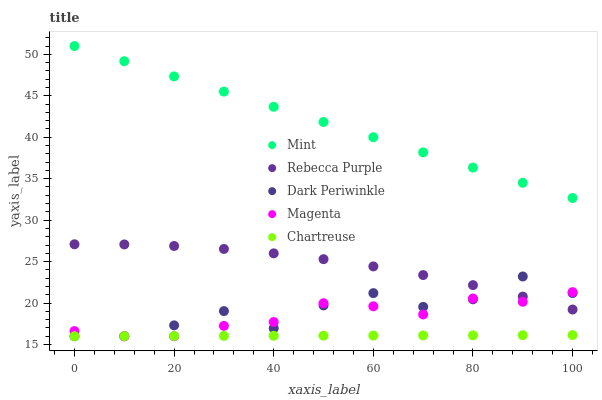Does Chartreuse have the minimum area under the curve?
Answer yes or no. Yes. Does Mint have the maximum area under the curve?
Answer yes or no. Yes. Does Rebecca Purple have the minimum area under the curve?
Answer yes or no. No. Does Rebecca Purple have the maximum area under the curve?
Answer yes or no. No. Is Mint the smoothest?
Answer yes or no. Yes. Is Dark Periwinkle the roughest?
Answer yes or no. Yes. Is Rebecca Purple the smoothest?
Answer yes or no. No. Is Rebecca Purple the roughest?
Answer yes or no. No. Does Magenta have the lowest value?
Answer yes or no. Yes. Does Rebecca Purple have the lowest value?
Answer yes or no. No. Does Mint have the highest value?
Answer yes or no. Yes. Does Rebecca Purple have the highest value?
Answer yes or no. No. Is Magenta less than Mint?
Answer yes or no. Yes. Is Mint greater than Dark Periwinkle?
Answer yes or no. Yes. Does Rebecca Purple intersect Magenta?
Answer yes or no. Yes. Is Rebecca Purple less than Magenta?
Answer yes or no. No. Is Rebecca Purple greater than Magenta?
Answer yes or no. No. Does Magenta intersect Mint?
Answer yes or no. No. 